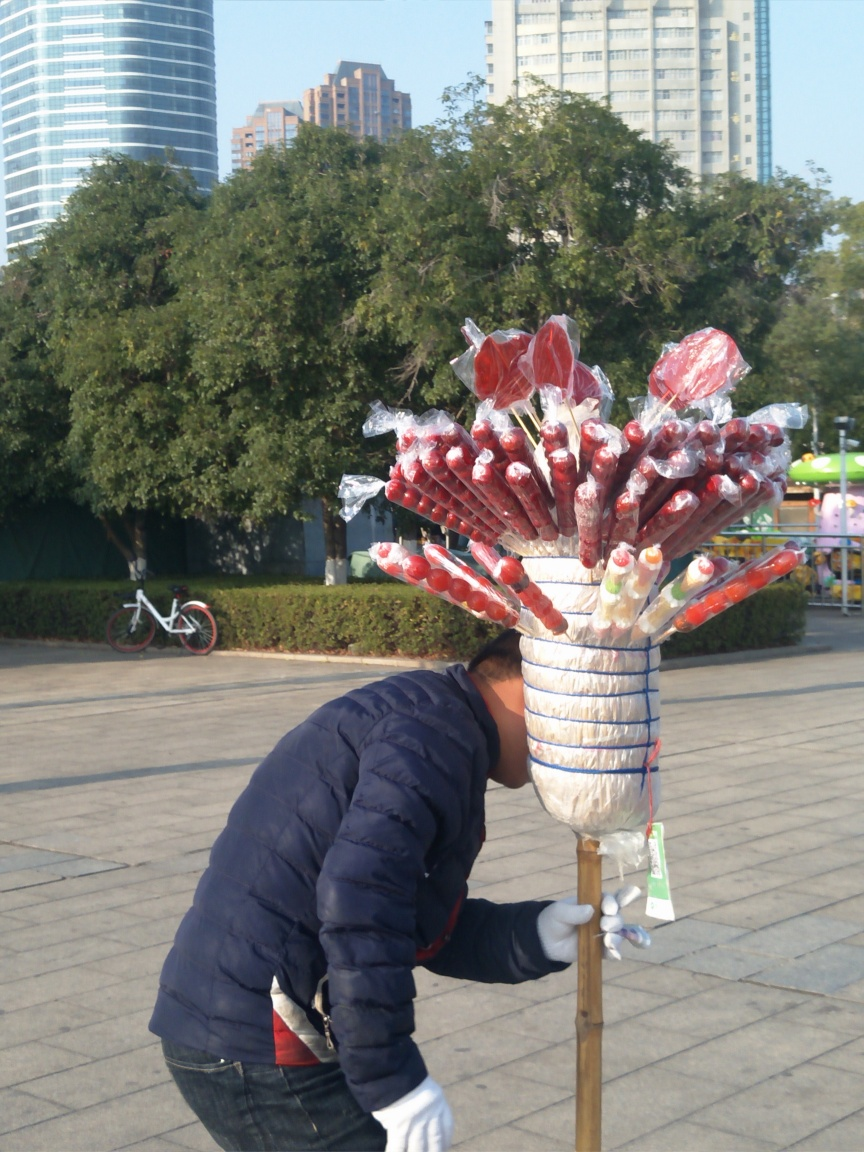What is the person in the image doing? The person appears to be setting up or tending to a candy apple stand. They seem to be arranging items on the stand or possibly selecting something from the lower part. Can you describe the items on the stand? Certainly! The stand holds an assortment of candy apples, with a glossy red coating, some sprinkled with nuts, and others plain. They are individually wrapped in plastic, creating a shiny, tempting display for potential customers. 